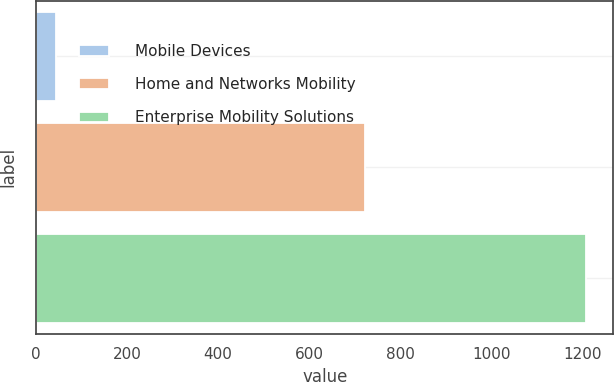<chart> <loc_0><loc_0><loc_500><loc_500><bar_chart><fcel>Mobile Devices<fcel>Home and Networks Mobility<fcel>Enterprise Mobility Solutions<nl><fcel>45<fcel>722<fcel>1208<nl></chart> 